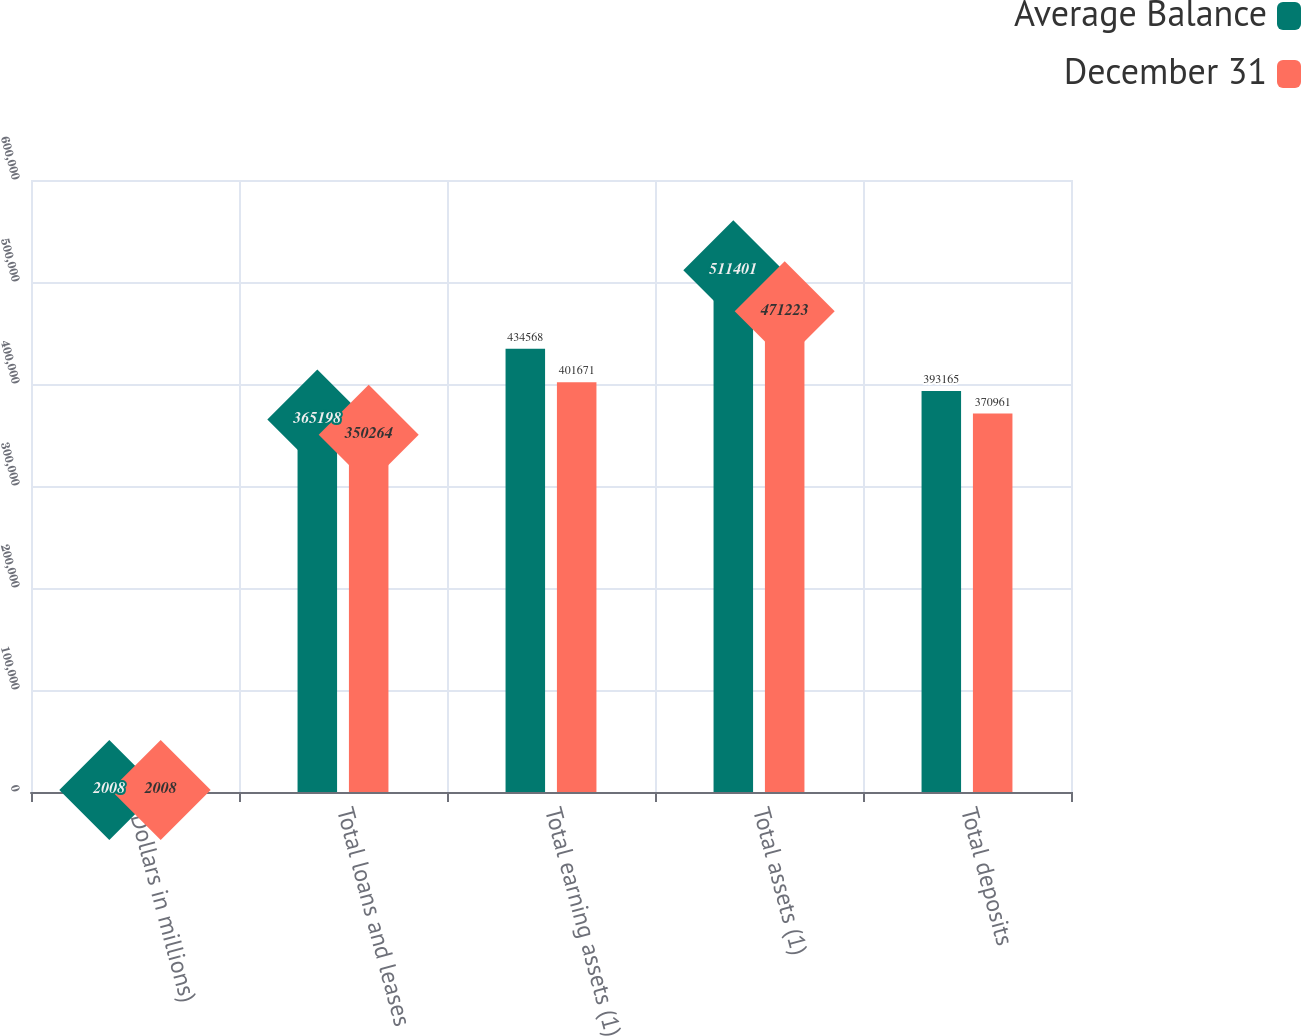Convert chart. <chart><loc_0><loc_0><loc_500><loc_500><stacked_bar_chart><ecel><fcel>(Dollars in millions)<fcel>Total loans and leases<fcel>Total earning assets (1)<fcel>Total assets (1)<fcel>Total deposits<nl><fcel>Average Balance<fcel>2008<fcel>365198<fcel>434568<fcel>511401<fcel>393165<nl><fcel>December 31<fcel>2008<fcel>350264<fcel>401671<fcel>471223<fcel>370961<nl></chart> 